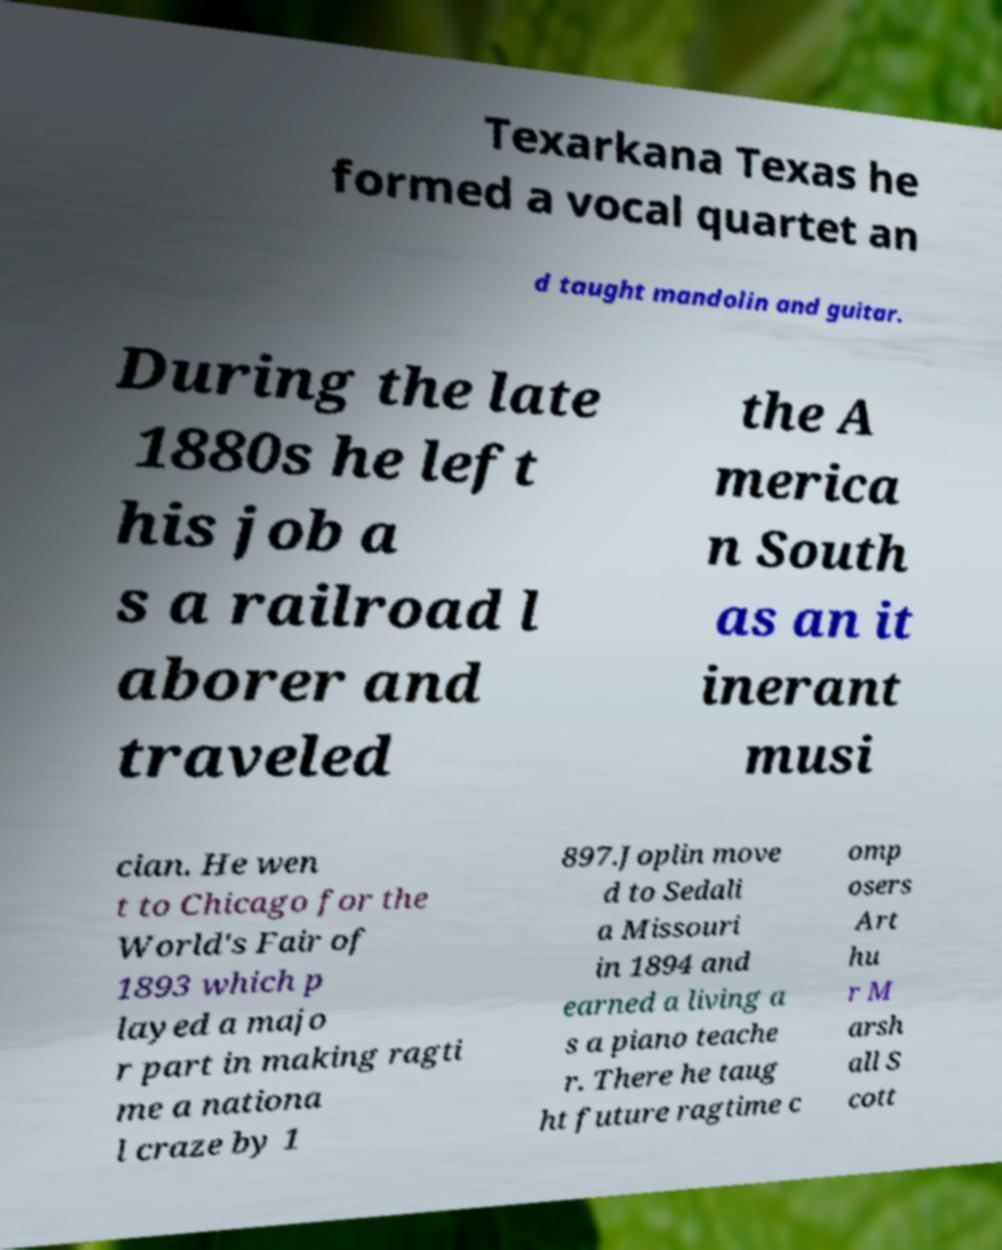Could you extract and type out the text from this image? Texarkana Texas he formed a vocal quartet an d taught mandolin and guitar. During the late 1880s he left his job a s a railroad l aborer and traveled the A merica n South as an it inerant musi cian. He wen t to Chicago for the World's Fair of 1893 which p layed a majo r part in making ragti me a nationa l craze by 1 897.Joplin move d to Sedali a Missouri in 1894 and earned a living a s a piano teache r. There he taug ht future ragtime c omp osers Art hu r M arsh all S cott 